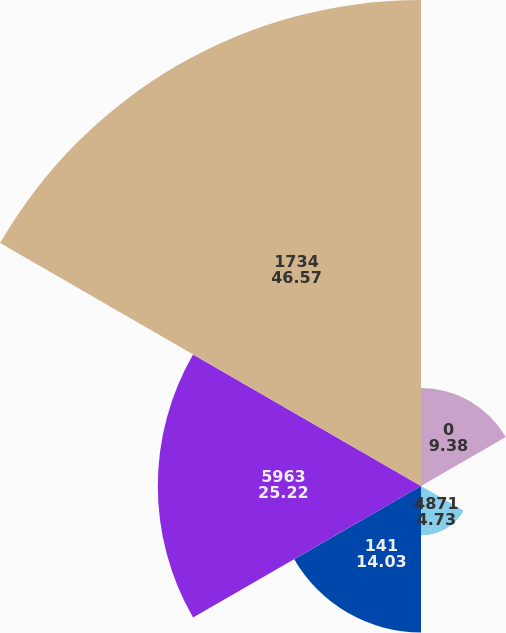<chart> <loc_0><loc_0><loc_500><loc_500><pie_chart><fcel>0<fcel>951<fcel>4871<fcel>141<fcel>5963<fcel>1734<nl><fcel>9.38%<fcel>0.08%<fcel>4.73%<fcel>14.03%<fcel>25.22%<fcel>46.57%<nl></chart> 